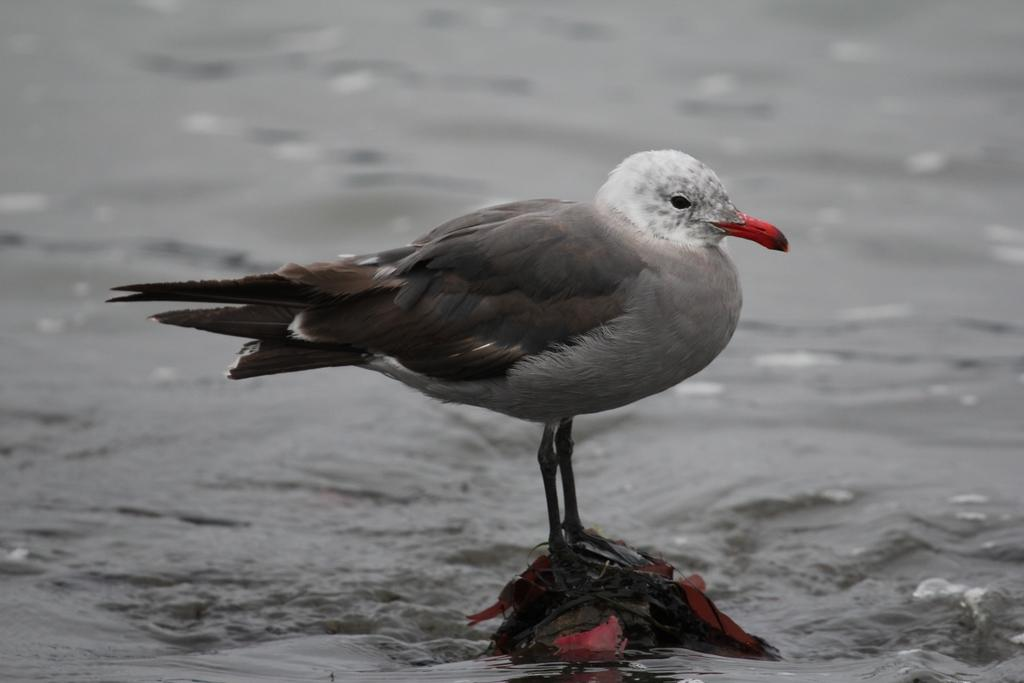What type of animal can be seen in the image? There is a bird in the image. What is the bird standing on? The bird is standing on a stone. Where is the stone located? The stone is in the water. In which direction is the bird facing? The bird is facing towards the right. What colors can be seen on the bird? The bird is in grey and white in color. What type of breakfast is the bird eating in the image? There is no breakfast present in the image; it only features a bird standing on a stone in the water. 